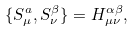<formula> <loc_0><loc_0><loc_500><loc_500>\{ S _ { \mu } ^ { a } , S _ { \nu } ^ { \beta } \} = H _ { \mu \nu } ^ { \alpha \beta } ,</formula> 